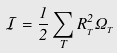<formula> <loc_0><loc_0><loc_500><loc_500>\mathcal { I } = \frac { 1 } { 2 } \sum _ { T } R _ { _ { T } } ^ { 2 } \Omega _ { _ { T } }</formula> 